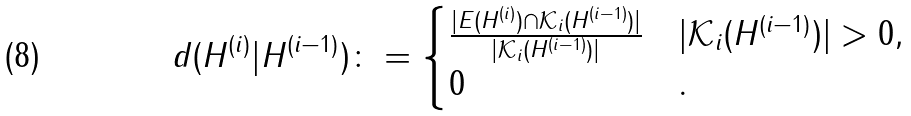Convert formula to latex. <formula><loc_0><loc_0><loc_500><loc_500>d ( H ^ { ( i ) } | H ^ { ( i - 1 ) } ) \colon = \begin{cases} \frac { | E ( H ^ { ( i ) } ) \cap \mathcal { K } _ { i } ( H ^ { ( i - 1 ) } ) | } { | \mathcal { K } _ { i } ( H ^ { ( i - 1 ) } ) | } & | \mathcal { K } _ { i } ( H ^ { ( i - 1 ) } ) | > 0 , \\ 0 & . \end{cases}</formula> 